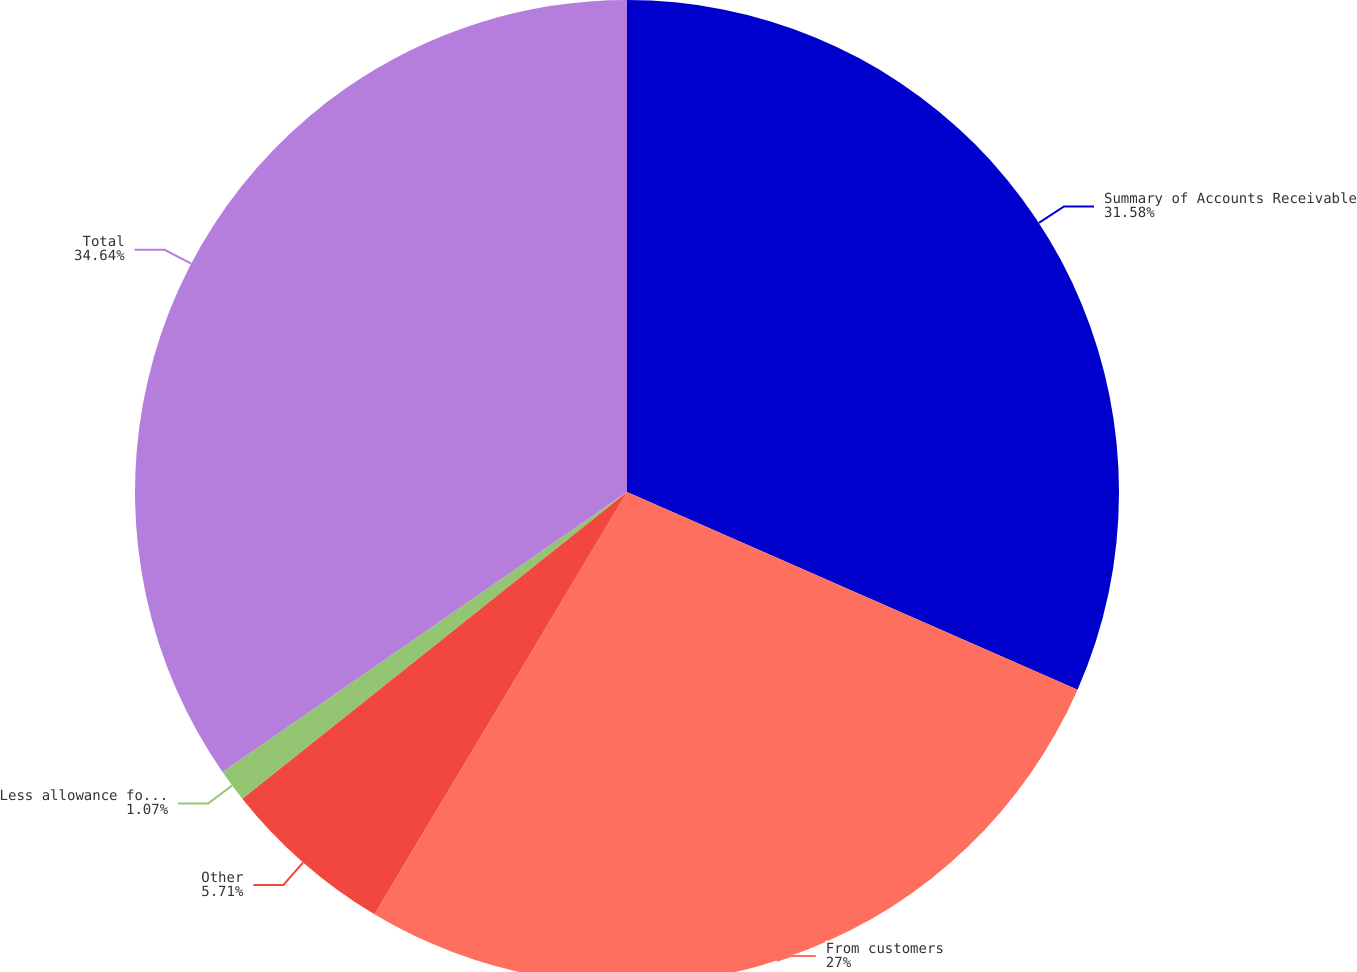Convert chart. <chart><loc_0><loc_0><loc_500><loc_500><pie_chart><fcel>Summary of Accounts Receivable<fcel>From customers<fcel>Other<fcel>Less allowance for doubtful<fcel>Total<nl><fcel>31.58%<fcel>27.0%<fcel>5.71%<fcel>1.07%<fcel>34.64%<nl></chart> 